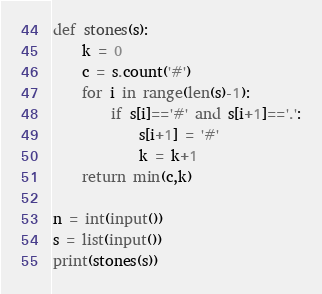<code> <loc_0><loc_0><loc_500><loc_500><_Python_>def stones(s):
    k = 0
    c = s.count('#')
    for i in range(len(s)-1):
        if s[i]=='#' and s[i+1]=='.':
            s[i+1] = '#'
            k = k+1
    return min(c,k)

n = int(input())
s = list(input())
print(stones(s))</code> 